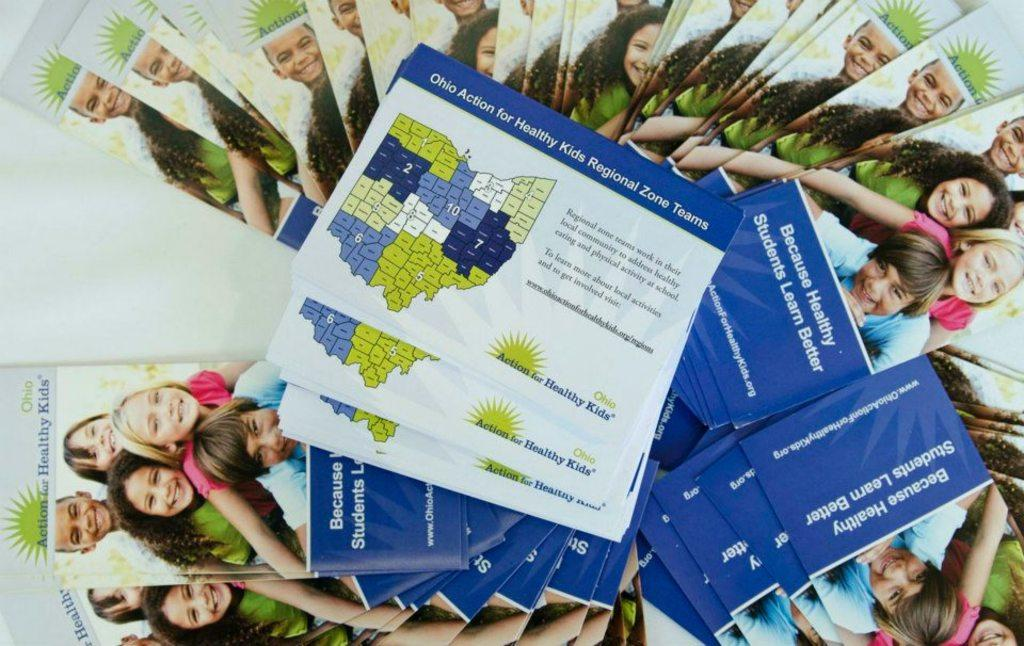What type of items can be seen on the table in the image? There are many books and pamphlets in the image. How are the books and pamphlets arranged on the table? The books and pamphlets are kept on a table. What type of coal is being used to heat the room in the image? There is no coal or indication of heating in the image; it only shows books and pamphlets on a table. 